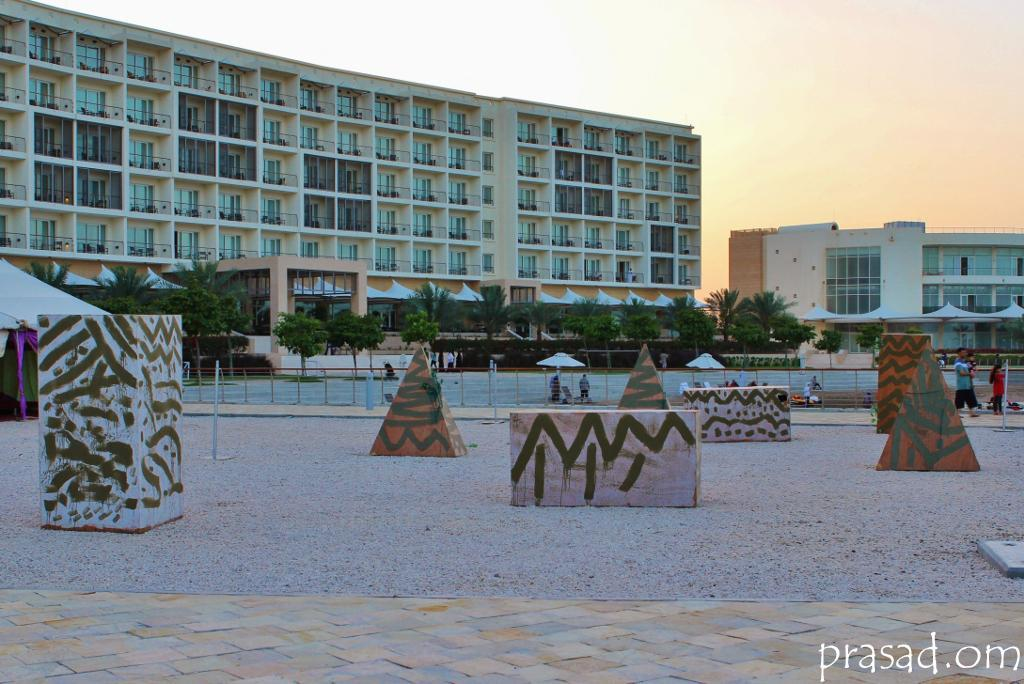What is located in front of the building in the image? There are objects and trees in front of the building in the image. What can be seen beneath the tents in the image? There are people beneath the tents in the image. Is there more than one building in the image? Yes, there is another building beside the first one. What type of room can be seen in the image? There is no room visible in the image; it features objects, trees, tents, and buildings. What is the occupation of the person beneath the tent? The image does not provide information about the occupation of the people beneath the tents. What color is the sheet draped over the tent? There is no sheet draped over the tent in the image. 